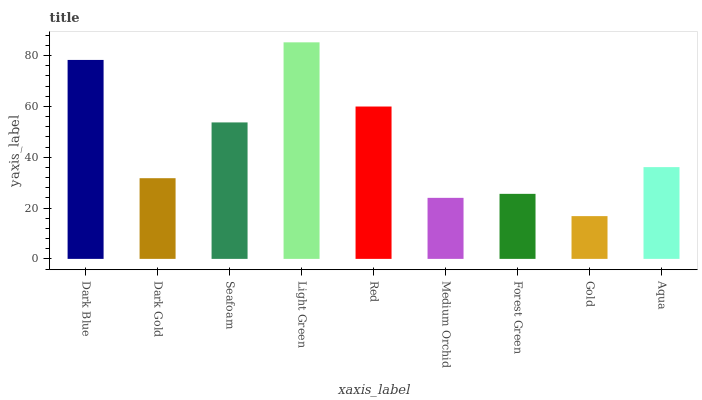Is Dark Gold the minimum?
Answer yes or no. No. Is Dark Gold the maximum?
Answer yes or no. No. Is Dark Blue greater than Dark Gold?
Answer yes or no. Yes. Is Dark Gold less than Dark Blue?
Answer yes or no. Yes. Is Dark Gold greater than Dark Blue?
Answer yes or no. No. Is Dark Blue less than Dark Gold?
Answer yes or no. No. Is Aqua the high median?
Answer yes or no. Yes. Is Aqua the low median?
Answer yes or no. Yes. Is Gold the high median?
Answer yes or no. No. Is Dark Gold the low median?
Answer yes or no. No. 